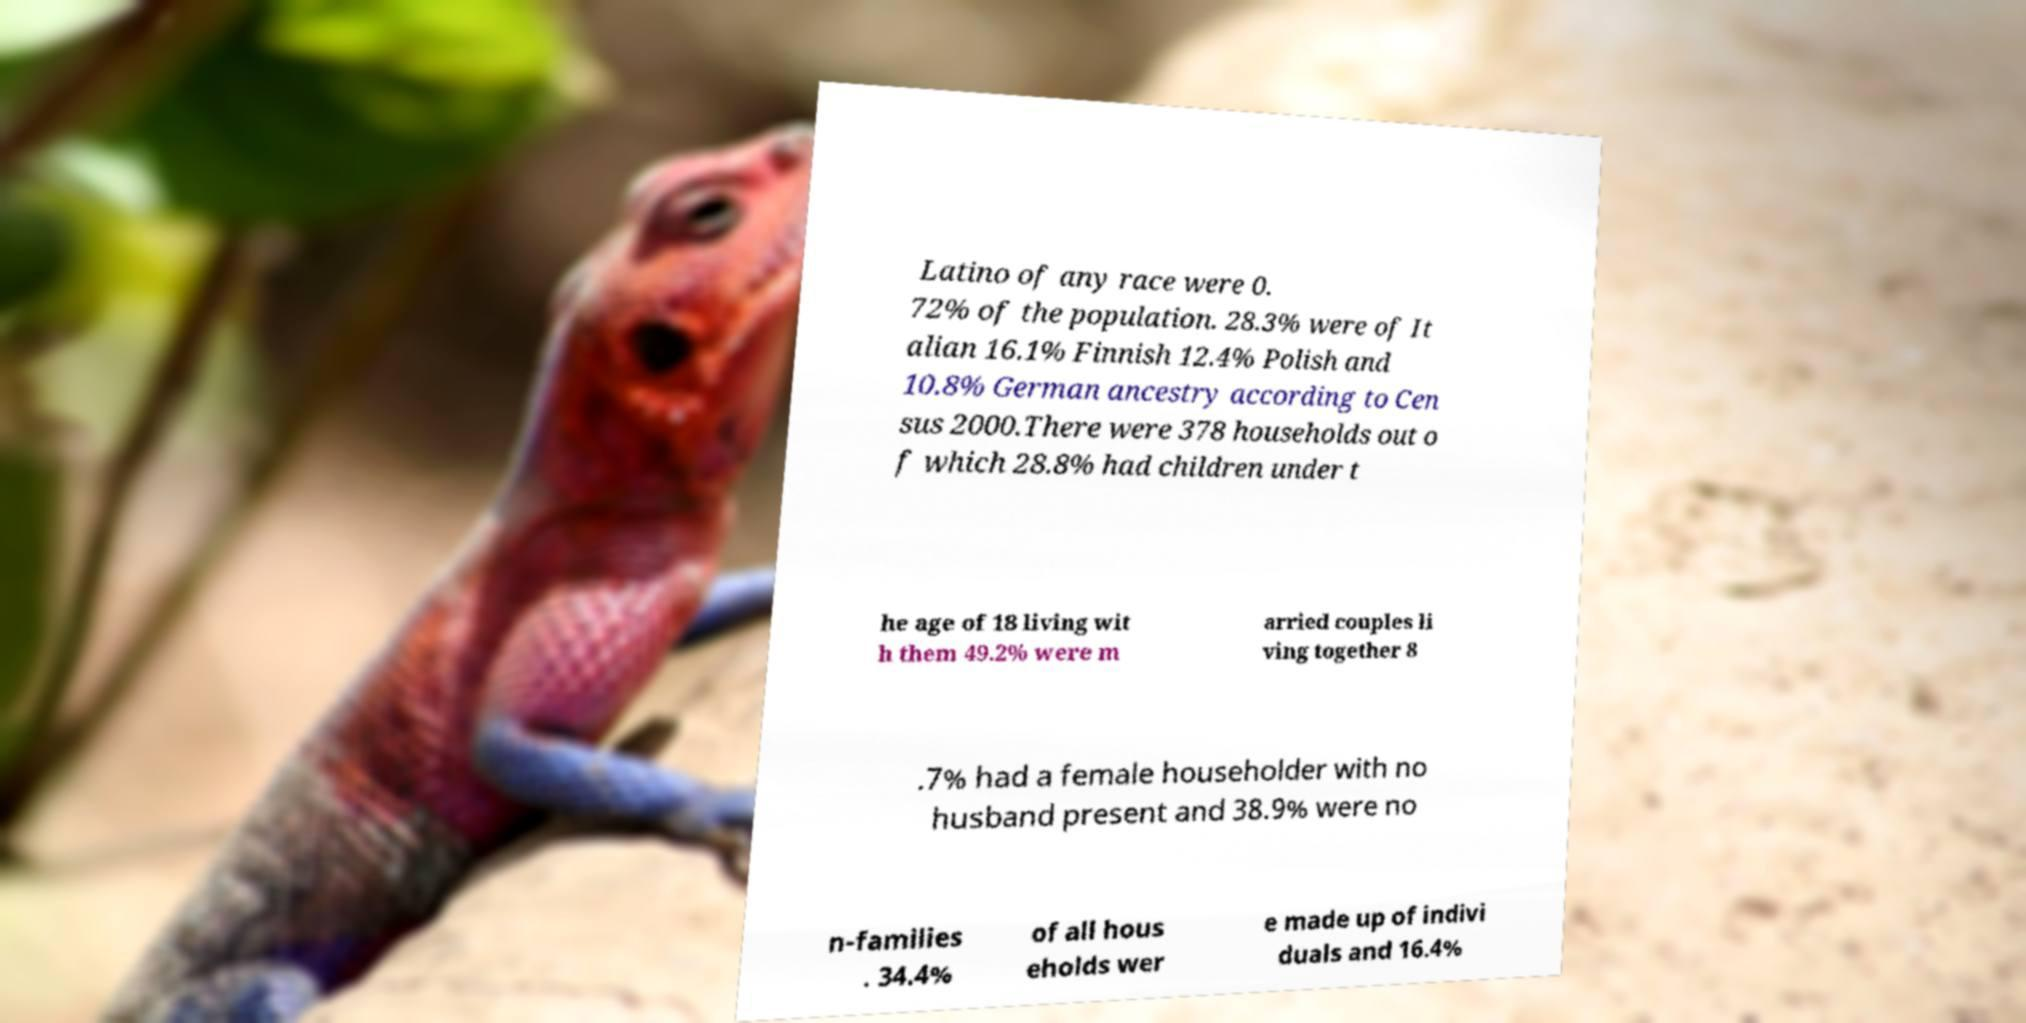Could you assist in decoding the text presented in this image and type it out clearly? Latino of any race were 0. 72% of the population. 28.3% were of It alian 16.1% Finnish 12.4% Polish and 10.8% German ancestry according to Cen sus 2000.There were 378 households out o f which 28.8% had children under t he age of 18 living wit h them 49.2% were m arried couples li ving together 8 .7% had a female householder with no husband present and 38.9% were no n-families . 34.4% of all hous eholds wer e made up of indivi duals and 16.4% 